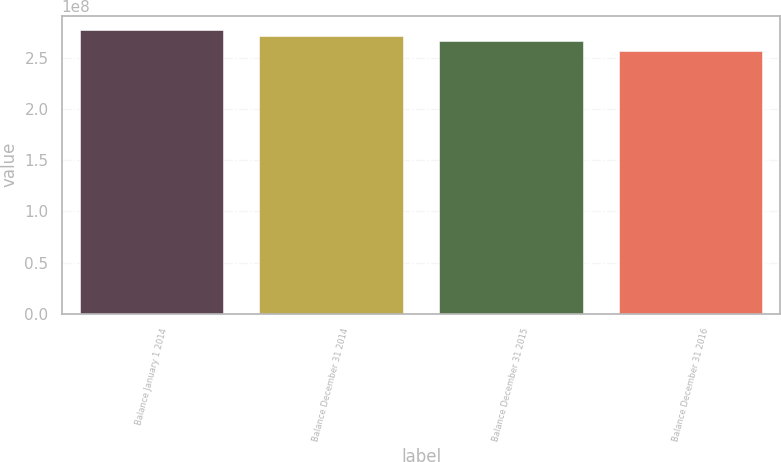Convert chart to OTSL. <chart><loc_0><loc_0><loc_500><loc_500><bar_chart><fcel>Balance January 1 2014<fcel>Balance December 31 2014<fcel>Balance December 31 2015<fcel>Balance December 31 2016<nl><fcel>2.77293e+08<fcel>2.71965e+08<fcel>2.66876e+08<fcel>2.5733e+08<nl></chart> 